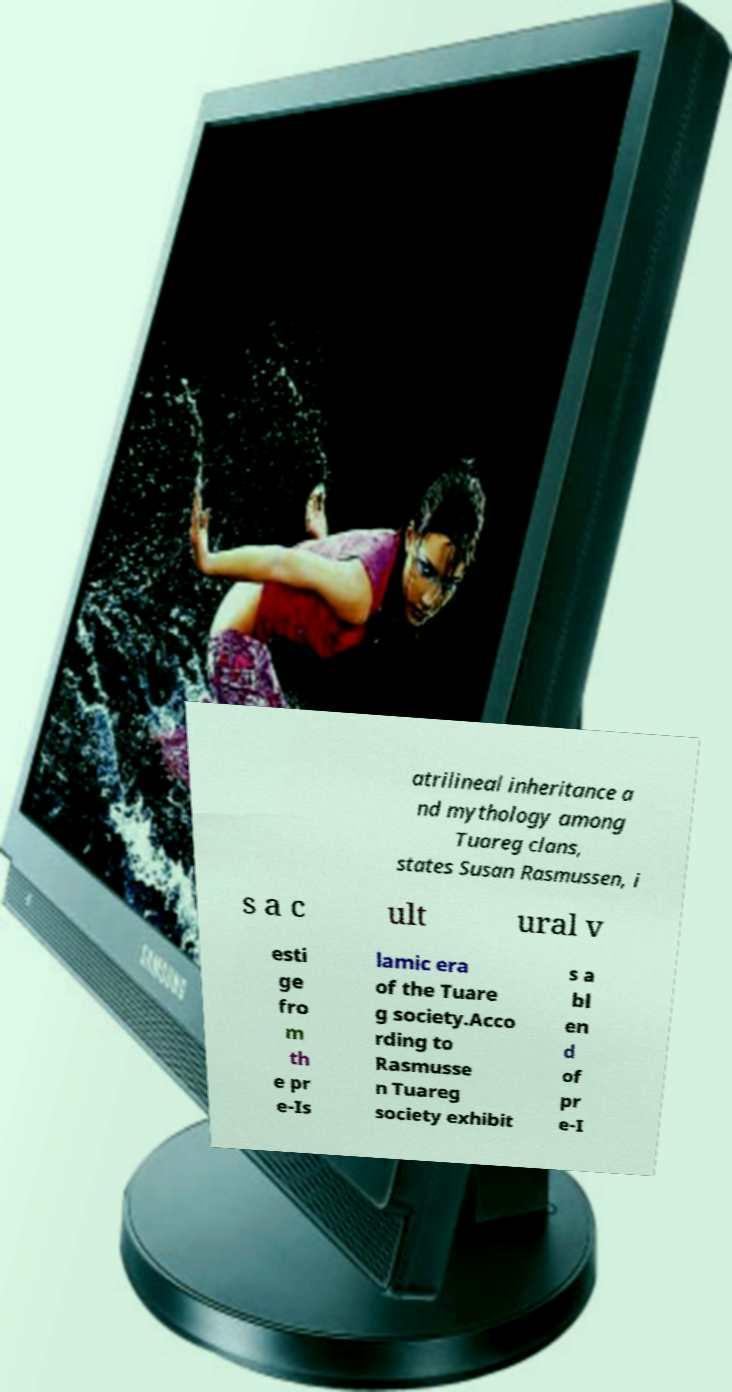Can you read and provide the text displayed in the image?This photo seems to have some interesting text. Can you extract and type it out for me? atrilineal inheritance a nd mythology among Tuareg clans, states Susan Rasmussen, i s a c ult ural v esti ge fro m th e pr e-Is lamic era of the Tuare g society.Acco rding to Rasmusse n Tuareg society exhibit s a bl en d of pr e-I 